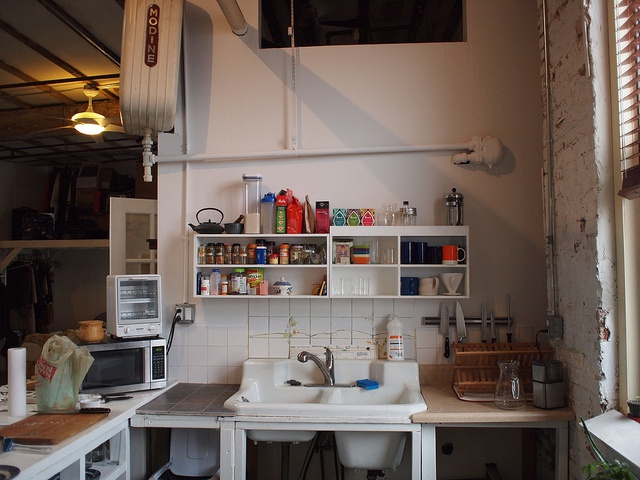Describe the objects in this image and their specific colors. I can see sink in black, darkgray, lightgray, and gray tones, microwave in black, gray, darkgray, and lightgray tones, vase in black, gray, and maroon tones, potted plant in black, darkgreen, and gray tones, and bottle in black, darkgray, and gray tones in this image. 